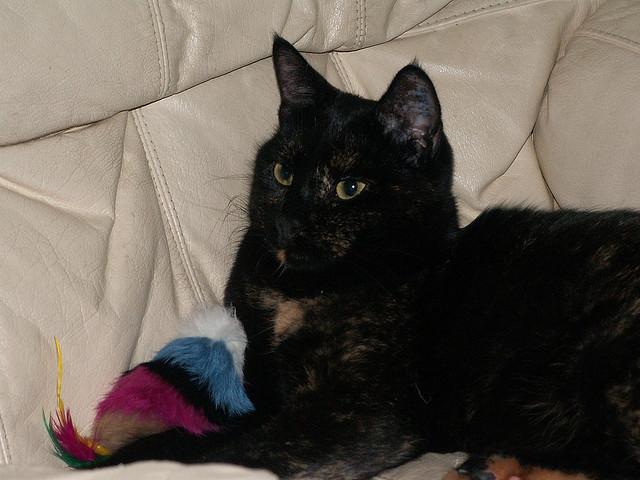What color is the cat?
Give a very brief answer. Black. What is the sofa made of?
Be succinct. Leather. What color is the couch?
Quick response, please. White. What is that colorful thing underneath the cat?
Give a very brief answer. Toy. Is the cat sleeping?
Quick response, please. No. Is this cat asleep?
Keep it brief. No. What animal is this?
Give a very brief answer. Cat. What is the cat looking at?
Be succinct. Person. What kind of furniture are the cats on?
Give a very brief answer. Couch. 